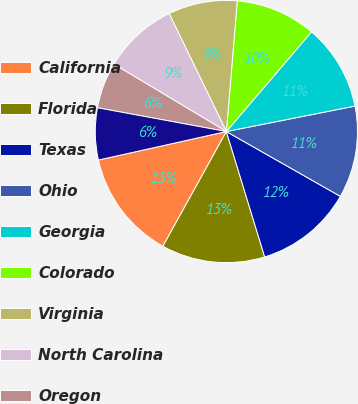<chart> <loc_0><loc_0><loc_500><loc_500><pie_chart><fcel>California<fcel>Florida<fcel>Texas<fcel>Ohio<fcel>Georgia<fcel>Colorado<fcel>Virginia<fcel>North Carolina<fcel>Oregon<fcel>Pennsylvania<nl><fcel>13.47%<fcel>12.76%<fcel>12.05%<fcel>11.34%<fcel>10.64%<fcel>9.93%<fcel>8.51%<fcel>9.22%<fcel>5.69%<fcel>6.39%<nl></chart> 